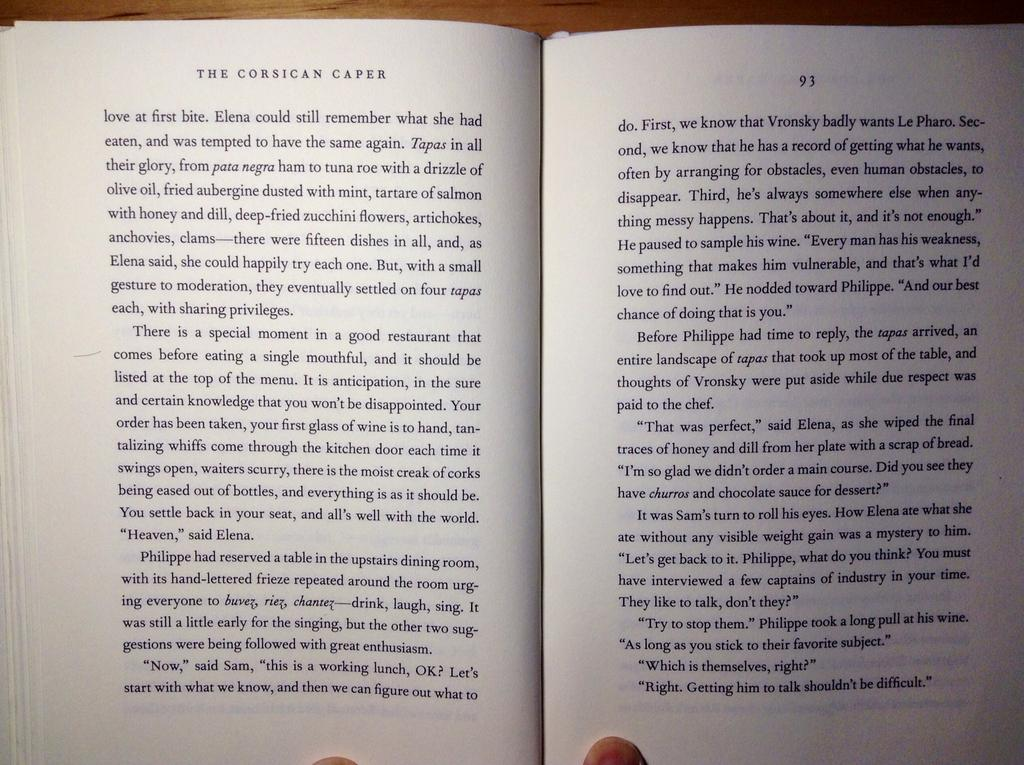<image>
Render a clear and concise summary of the photo. Pages 92 and 93 of The Corsican Caper are shown being held open by two fingers. 